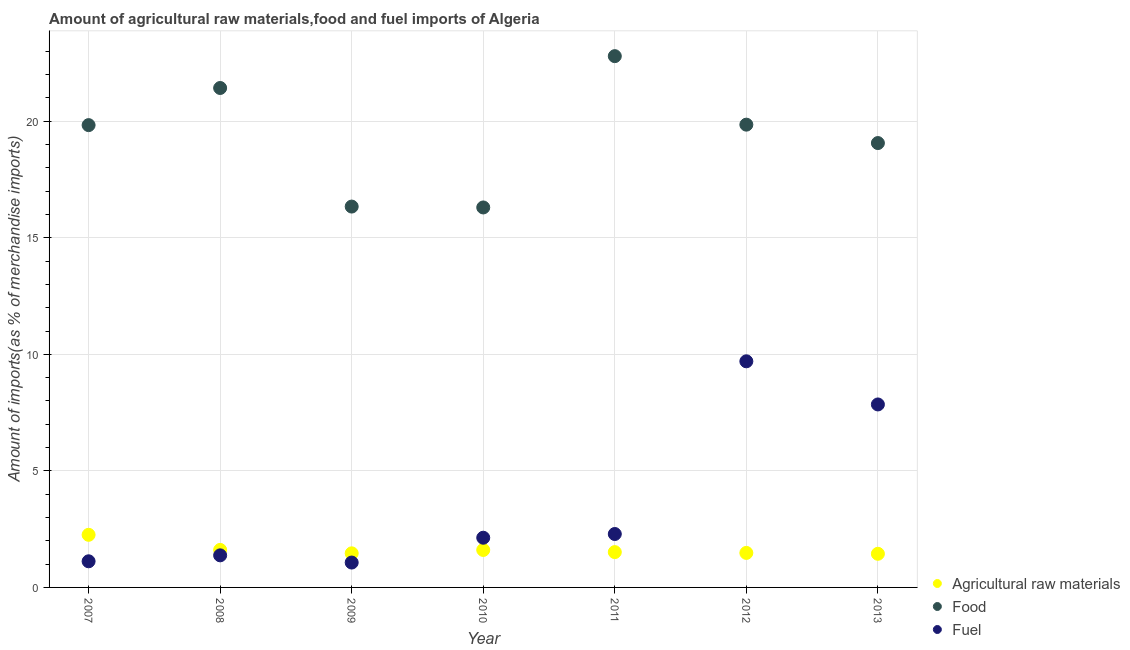What is the percentage of raw materials imports in 2009?
Offer a very short reply. 1.46. Across all years, what is the maximum percentage of food imports?
Provide a succinct answer. 22.79. Across all years, what is the minimum percentage of raw materials imports?
Provide a short and direct response. 1.44. In which year was the percentage of fuel imports maximum?
Your response must be concise. 2012. What is the total percentage of food imports in the graph?
Keep it short and to the point. 135.6. What is the difference between the percentage of raw materials imports in 2007 and that in 2013?
Give a very brief answer. 0.81. What is the difference between the percentage of fuel imports in 2010 and the percentage of raw materials imports in 2008?
Keep it short and to the point. 0.52. What is the average percentage of food imports per year?
Ensure brevity in your answer.  19.37. In the year 2010, what is the difference between the percentage of fuel imports and percentage of food imports?
Provide a short and direct response. -14.17. In how many years, is the percentage of raw materials imports greater than 15 %?
Ensure brevity in your answer.  0. What is the ratio of the percentage of food imports in 2008 to that in 2013?
Offer a very short reply. 1.12. Is the difference between the percentage of raw materials imports in 2011 and 2012 greater than the difference between the percentage of food imports in 2011 and 2012?
Your answer should be compact. No. What is the difference between the highest and the second highest percentage of raw materials imports?
Give a very brief answer. 0.65. What is the difference between the highest and the lowest percentage of raw materials imports?
Offer a terse response. 0.81. Is it the case that in every year, the sum of the percentage of raw materials imports and percentage of food imports is greater than the percentage of fuel imports?
Provide a succinct answer. Yes. How many years are there in the graph?
Provide a succinct answer. 7. What is the difference between two consecutive major ticks on the Y-axis?
Make the answer very short. 5. How are the legend labels stacked?
Keep it short and to the point. Vertical. What is the title of the graph?
Provide a short and direct response. Amount of agricultural raw materials,food and fuel imports of Algeria. Does "Maunufacturing" appear as one of the legend labels in the graph?
Offer a very short reply. No. What is the label or title of the Y-axis?
Offer a terse response. Amount of imports(as % of merchandise imports). What is the Amount of imports(as % of merchandise imports) of Agricultural raw materials in 2007?
Offer a very short reply. 2.26. What is the Amount of imports(as % of merchandise imports) in Food in 2007?
Provide a short and direct response. 19.83. What is the Amount of imports(as % of merchandise imports) in Fuel in 2007?
Offer a terse response. 1.12. What is the Amount of imports(as % of merchandise imports) of Agricultural raw materials in 2008?
Offer a very short reply. 1.61. What is the Amount of imports(as % of merchandise imports) in Food in 2008?
Your answer should be compact. 21.42. What is the Amount of imports(as % of merchandise imports) of Fuel in 2008?
Provide a short and direct response. 1.38. What is the Amount of imports(as % of merchandise imports) in Agricultural raw materials in 2009?
Ensure brevity in your answer.  1.46. What is the Amount of imports(as % of merchandise imports) of Food in 2009?
Ensure brevity in your answer.  16.34. What is the Amount of imports(as % of merchandise imports) in Fuel in 2009?
Make the answer very short. 1.07. What is the Amount of imports(as % of merchandise imports) in Agricultural raw materials in 2010?
Keep it short and to the point. 1.61. What is the Amount of imports(as % of merchandise imports) in Food in 2010?
Provide a succinct answer. 16.3. What is the Amount of imports(as % of merchandise imports) of Fuel in 2010?
Your answer should be very brief. 2.13. What is the Amount of imports(as % of merchandise imports) of Agricultural raw materials in 2011?
Make the answer very short. 1.52. What is the Amount of imports(as % of merchandise imports) in Food in 2011?
Keep it short and to the point. 22.79. What is the Amount of imports(as % of merchandise imports) in Fuel in 2011?
Your answer should be compact. 2.29. What is the Amount of imports(as % of merchandise imports) of Agricultural raw materials in 2012?
Give a very brief answer. 1.48. What is the Amount of imports(as % of merchandise imports) in Food in 2012?
Your answer should be compact. 19.85. What is the Amount of imports(as % of merchandise imports) of Fuel in 2012?
Keep it short and to the point. 9.7. What is the Amount of imports(as % of merchandise imports) of Agricultural raw materials in 2013?
Offer a terse response. 1.44. What is the Amount of imports(as % of merchandise imports) of Food in 2013?
Your answer should be compact. 19.06. What is the Amount of imports(as % of merchandise imports) in Fuel in 2013?
Keep it short and to the point. 7.85. Across all years, what is the maximum Amount of imports(as % of merchandise imports) of Agricultural raw materials?
Offer a very short reply. 2.26. Across all years, what is the maximum Amount of imports(as % of merchandise imports) in Food?
Your answer should be very brief. 22.79. Across all years, what is the maximum Amount of imports(as % of merchandise imports) in Fuel?
Provide a succinct answer. 9.7. Across all years, what is the minimum Amount of imports(as % of merchandise imports) in Agricultural raw materials?
Your answer should be very brief. 1.44. Across all years, what is the minimum Amount of imports(as % of merchandise imports) in Food?
Your answer should be compact. 16.3. Across all years, what is the minimum Amount of imports(as % of merchandise imports) in Fuel?
Your answer should be compact. 1.07. What is the total Amount of imports(as % of merchandise imports) of Agricultural raw materials in the graph?
Your answer should be compact. 11.38. What is the total Amount of imports(as % of merchandise imports) in Food in the graph?
Your response must be concise. 135.6. What is the total Amount of imports(as % of merchandise imports) of Fuel in the graph?
Provide a succinct answer. 25.54. What is the difference between the Amount of imports(as % of merchandise imports) in Agricultural raw materials in 2007 and that in 2008?
Offer a terse response. 0.65. What is the difference between the Amount of imports(as % of merchandise imports) in Food in 2007 and that in 2008?
Offer a terse response. -1.59. What is the difference between the Amount of imports(as % of merchandise imports) in Fuel in 2007 and that in 2008?
Give a very brief answer. -0.25. What is the difference between the Amount of imports(as % of merchandise imports) in Agricultural raw materials in 2007 and that in 2009?
Provide a short and direct response. 0.79. What is the difference between the Amount of imports(as % of merchandise imports) in Food in 2007 and that in 2009?
Keep it short and to the point. 3.49. What is the difference between the Amount of imports(as % of merchandise imports) in Fuel in 2007 and that in 2009?
Offer a terse response. 0.05. What is the difference between the Amount of imports(as % of merchandise imports) of Agricultural raw materials in 2007 and that in 2010?
Keep it short and to the point. 0.65. What is the difference between the Amount of imports(as % of merchandise imports) of Food in 2007 and that in 2010?
Provide a short and direct response. 3.53. What is the difference between the Amount of imports(as % of merchandise imports) in Fuel in 2007 and that in 2010?
Provide a short and direct response. -1.01. What is the difference between the Amount of imports(as % of merchandise imports) in Agricultural raw materials in 2007 and that in 2011?
Give a very brief answer. 0.74. What is the difference between the Amount of imports(as % of merchandise imports) of Food in 2007 and that in 2011?
Make the answer very short. -2.96. What is the difference between the Amount of imports(as % of merchandise imports) in Fuel in 2007 and that in 2011?
Keep it short and to the point. -1.17. What is the difference between the Amount of imports(as % of merchandise imports) in Agricultural raw materials in 2007 and that in 2012?
Keep it short and to the point. 0.78. What is the difference between the Amount of imports(as % of merchandise imports) of Food in 2007 and that in 2012?
Offer a terse response. -0.02. What is the difference between the Amount of imports(as % of merchandise imports) of Fuel in 2007 and that in 2012?
Offer a very short reply. -8.58. What is the difference between the Amount of imports(as % of merchandise imports) of Agricultural raw materials in 2007 and that in 2013?
Provide a short and direct response. 0.81. What is the difference between the Amount of imports(as % of merchandise imports) of Food in 2007 and that in 2013?
Give a very brief answer. 0.77. What is the difference between the Amount of imports(as % of merchandise imports) of Fuel in 2007 and that in 2013?
Offer a terse response. -6.73. What is the difference between the Amount of imports(as % of merchandise imports) in Agricultural raw materials in 2008 and that in 2009?
Ensure brevity in your answer.  0.15. What is the difference between the Amount of imports(as % of merchandise imports) in Food in 2008 and that in 2009?
Keep it short and to the point. 5.09. What is the difference between the Amount of imports(as % of merchandise imports) of Fuel in 2008 and that in 2009?
Your response must be concise. 0.31. What is the difference between the Amount of imports(as % of merchandise imports) in Agricultural raw materials in 2008 and that in 2010?
Offer a terse response. 0. What is the difference between the Amount of imports(as % of merchandise imports) in Food in 2008 and that in 2010?
Offer a terse response. 5.12. What is the difference between the Amount of imports(as % of merchandise imports) in Fuel in 2008 and that in 2010?
Ensure brevity in your answer.  -0.76. What is the difference between the Amount of imports(as % of merchandise imports) of Agricultural raw materials in 2008 and that in 2011?
Give a very brief answer. 0.09. What is the difference between the Amount of imports(as % of merchandise imports) of Food in 2008 and that in 2011?
Offer a very short reply. -1.37. What is the difference between the Amount of imports(as % of merchandise imports) of Fuel in 2008 and that in 2011?
Your answer should be very brief. -0.92. What is the difference between the Amount of imports(as % of merchandise imports) of Agricultural raw materials in 2008 and that in 2012?
Give a very brief answer. 0.13. What is the difference between the Amount of imports(as % of merchandise imports) in Food in 2008 and that in 2012?
Provide a short and direct response. 1.57. What is the difference between the Amount of imports(as % of merchandise imports) of Fuel in 2008 and that in 2012?
Your response must be concise. -8.32. What is the difference between the Amount of imports(as % of merchandise imports) in Agricultural raw materials in 2008 and that in 2013?
Your answer should be compact. 0.17. What is the difference between the Amount of imports(as % of merchandise imports) of Food in 2008 and that in 2013?
Give a very brief answer. 2.36. What is the difference between the Amount of imports(as % of merchandise imports) in Fuel in 2008 and that in 2013?
Ensure brevity in your answer.  -6.47. What is the difference between the Amount of imports(as % of merchandise imports) of Agricultural raw materials in 2009 and that in 2010?
Offer a terse response. -0.14. What is the difference between the Amount of imports(as % of merchandise imports) in Food in 2009 and that in 2010?
Keep it short and to the point. 0.04. What is the difference between the Amount of imports(as % of merchandise imports) in Fuel in 2009 and that in 2010?
Offer a terse response. -1.06. What is the difference between the Amount of imports(as % of merchandise imports) of Agricultural raw materials in 2009 and that in 2011?
Offer a terse response. -0.05. What is the difference between the Amount of imports(as % of merchandise imports) of Food in 2009 and that in 2011?
Ensure brevity in your answer.  -6.45. What is the difference between the Amount of imports(as % of merchandise imports) of Fuel in 2009 and that in 2011?
Offer a very short reply. -1.23. What is the difference between the Amount of imports(as % of merchandise imports) of Agricultural raw materials in 2009 and that in 2012?
Provide a succinct answer. -0.02. What is the difference between the Amount of imports(as % of merchandise imports) in Food in 2009 and that in 2012?
Your response must be concise. -3.51. What is the difference between the Amount of imports(as % of merchandise imports) of Fuel in 2009 and that in 2012?
Provide a succinct answer. -8.63. What is the difference between the Amount of imports(as % of merchandise imports) in Food in 2009 and that in 2013?
Provide a succinct answer. -2.72. What is the difference between the Amount of imports(as % of merchandise imports) of Fuel in 2009 and that in 2013?
Make the answer very short. -6.78. What is the difference between the Amount of imports(as % of merchandise imports) of Agricultural raw materials in 2010 and that in 2011?
Your response must be concise. 0.09. What is the difference between the Amount of imports(as % of merchandise imports) in Food in 2010 and that in 2011?
Ensure brevity in your answer.  -6.49. What is the difference between the Amount of imports(as % of merchandise imports) in Fuel in 2010 and that in 2011?
Keep it short and to the point. -0.16. What is the difference between the Amount of imports(as % of merchandise imports) of Agricultural raw materials in 2010 and that in 2012?
Keep it short and to the point. 0.13. What is the difference between the Amount of imports(as % of merchandise imports) in Food in 2010 and that in 2012?
Offer a terse response. -3.55. What is the difference between the Amount of imports(as % of merchandise imports) in Fuel in 2010 and that in 2012?
Make the answer very short. -7.57. What is the difference between the Amount of imports(as % of merchandise imports) in Agricultural raw materials in 2010 and that in 2013?
Give a very brief answer. 0.16. What is the difference between the Amount of imports(as % of merchandise imports) of Food in 2010 and that in 2013?
Make the answer very short. -2.76. What is the difference between the Amount of imports(as % of merchandise imports) in Fuel in 2010 and that in 2013?
Give a very brief answer. -5.72. What is the difference between the Amount of imports(as % of merchandise imports) of Agricultural raw materials in 2011 and that in 2012?
Your response must be concise. 0.03. What is the difference between the Amount of imports(as % of merchandise imports) of Food in 2011 and that in 2012?
Your answer should be very brief. 2.94. What is the difference between the Amount of imports(as % of merchandise imports) of Fuel in 2011 and that in 2012?
Offer a very short reply. -7.41. What is the difference between the Amount of imports(as % of merchandise imports) in Agricultural raw materials in 2011 and that in 2013?
Your response must be concise. 0.07. What is the difference between the Amount of imports(as % of merchandise imports) of Food in 2011 and that in 2013?
Keep it short and to the point. 3.73. What is the difference between the Amount of imports(as % of merchandise imports) of Fuel in 2011 and that in 2013?
Give a very brief answer. -5.56. What is the difference between the Amount of imports(as % of merchandise imports) of Agricultural raw materials in 2012 and that in 2013?
Your response must be concise. 0.04. What is the difference between the Amount of imports(as % of merchandise imports) of Food in 2012 and that in 2013?
Your answer should be very brief. 0.79. What is the difference between the Amount of imports(as % of merchandise imports) of Fuel in 2012 and that in 2013?
Give a very brief answer. 1.85. What is the difference between the Amount of imports(as % of merchandise imports) in Agricultural raw materials in 2007 and the Amount of imports(as % of merchandise imports) in Food in 2008?
Provide a short and direct response. -19.17. What is the difference between the Amount of imports(as % of merchandise imports) in Agricultural raw materials in 2007 and the Amount of imports(as % of merchandise imports) in Fuel in 2008?
Give a very brief answer. 0.88. What is the difference between the Amount of imports(as % of merchandise imports) of Food in 2007 and the Amount of imports(as % of merchandise imports) of Fuel in 2008?
Provide a short and direct response. 18.46. What is the difference between the Amount of imports(as % of merchandise imports) in Agricultural raw materials in 2007 and the Amount of imports(as % of merchandise imports) in Food in 2009?
Offer a terse response. -14.08. What is the difference between the Amount of imports(as % of merchandise imports) in Agricultural raw materials in 2007 and the Amount of imports(as % of merchandise imports) in Fuel in 2009?
Give a very brief answer. 1.19. What is the difference between the Amount of imports(as % of merchandise imports) in Food in 2007 and the Amount of imports(as % of merchandise imports) in Fuel in 2009?
Your response must be concise. 18.77. What is the difference between the Amount of imports(as % of merchandise imports) in Agricultural raw materials in 2007 and the Amount of imports(as % of merchandise imports) in Food in 2010?
Keep it short and to the point. -14.04. What is the difference between the Amount of imports(as % of merchandise imports) in Agricultural raw materials in 2007 and the Amount of imports(as % of merchandise imports) in Fuel in 2010?
Your answer should be very brief. 0.13. What is the difference between the Amount of imports(as % of merchandise imports) of Food in 2007 and the Amount of imports(as % of merchandise imports) of Fuel in 2010?
Provide a succinct answer. 17.7. What is the difference between the Amount of imports(as % of merchandise imports) of Agricultural raw materials in 2007 and the Amount of imports(as % of merchandise imports) of Food in 2011?
Your answer should be compact. -20.53. What is the difference between the Amount of imports(as % of merchandise imports) of Agricultural raw materials in 2007 and the Amount of imports(as % of merchandise imports) of Fuel in 2011?
Keep it short and to the point. -0.03. What is the difference between the Amount of imports(as % of merchandise imports) of Food in 2007 and the Amount of imports(as % of merchandise imports) of Fuel in 2011?
Provide a short and direct response. 17.54. What is the difference between the Amount of imports(as % of merchandise imports) of Agricultural raw materials in 2007 and the Amount of imports(as % of merchandise imports) of Food in 2012?
Offer a very short reply. -17.6. What is the difference between the Amount of imports(as % of merchandise imports) of Agricultural raw materials in 2007 and the Amount of imports(as % of merchandise imports) of Fuel in 2012?
Make the answer very short. -7.44. What is the difference between the Amount of imports(as % of merchandise imports) in Food in 2007 and the Amount of imports(as % of merchandise imports) in Fuel in 2012?
Keep it short and to the point. 10.13. What is the difference between the Amount of imports(as % of merchandise imports) of Agricultural raw materials in 2007 and the Amount of imports(as % of merchandise imports) of Food in 2013?
Offer a terse response. -16.81. What is the difference between the Amount of imports(as % of merchandise imports) of Agricultural raw materials in 2007 and the Amount of imports(as % of merchandise imports) of Fuel in 2013?
Offer a very short reply. -5.59. What is the difference between the Amount of imports(as % of merchandise imports) in Food in 2007 and the Amount of imports(as % of merchandise imports) in Fuel in 2013?
Give a very brief answer. 11.98. What is the difference between the Amount of imports(as % of merchandise imports) in Agricultural raw materials in 2008 and the Amount of imports(as % of merchandise imports) in Food in 2009?
Offer a terse response. -14.73. What is the difference between the Amount of imports(as % of merchandise imports) in Agricultural raw materials in 2008 and the Amount of imports(as % of merchandise imports) in Fuel in 2009?
Ensure brevity in your answer.  0.54. What is the difference between the Amount of imports(as % of merchandise imports) of Food in 2008 and the Amount of imports(as % of merchandise imports) of Fuel in 2009?
Offer a terse response. 20.36. What is the difference between the Amount of imports(as % of merchandise imports) in Agricultural raw materials in 2008 and the Amount of imports(as % of merchandise imports) in Food in 2010?
Offer a very short reply. -14.69. What is the difference between the Amount of imports(as % of merchandise imports) in Agricultural raw materials in 2008 and the Amount of imports(as % of merchandise imports) in Fuel in 2010?
Your answer should be compact. -0.52. What is the difference between the Amount of imports(as % of merchandise imports) in Food in 2008 and the Amount of imports(as % of merchandise imports) in Fuel in 2010?
Your answer should be compact. 19.29. What is the difference between the Amount of imports(as % of merchandise imports) in Agricultural raw materials in 2008 and the Amount of imports(as % of merchandise imports) in Food in 2011?
Give a very brief answer. -21.18. What is the difference between the Amount of imports(as % of merchandise imports) in Agricultural raw materials in 2008 and the Amount of imports(as % of merchandise imports) in Fuel in 2011?
Give a very brief answer. -0.68. What is the difference between the Amount of imports(as % of merchandise imports) of Food in 2008 and the Amount of imports(as % of merchandise imports) of Fuel in 2011?
Make the answer very short. 19.13. What is the difference between the Amount of imports(as % of merchandise imports) of Agricultural raw materials in 2008 and the Amount of imports(as % of merchandise imports) of Food in 2012?
Offer a very short reply. -18.24. What is the difference between the Amount of imports(as % of merchandise imports) in Agricultural raw materials in 2008 and the Amount of imports(as % of merchandise imports) in Fuel in 2012?
Give a very brief answer. -8.09. What is the difference between the Amount of imports(as % of merchandise imports) in Food in 2008 and the Amount of imports(as % of merchandise imports) in Fuel in 2012?
Offer a terse response. 11.72. What is the difference between the Amount of imports(as % of merchandise imports) in Agricultural raw materials in 2008 and the Amount of imports(as % of merchandise imports) in Food in 2013?
Your answer should be very brief. -17.45. What is the difference between the Amount of imports(as % of merchandise imports) of Agricultural raw materials in 2008 and the Amount of imports(as % of merchandise imports) of Fuel in 2013?
Keep it short and to the point. -6.24. What is the difference between the Amount of imports(as % of merchandise imports) in Food in 2008 and the Amount of imports(as % of merchandise imports) in Fuel in 2013?
Your answer should be compact. 13.58. What is the difference between the Amount of imports(as % of merchandise imports) in Agricultural raw materials in 2009 and the Amount of imports(as % of merchandise imports) in Food in 2010?
Provide a succinct answer. -14.84. What is the difference between the Amount of imports(as % of merchandise imports) of Agricultural raw materials in 2009 and the Amount of imports(as % of merchandise imports) of Fuel in 2010?
Make the answer very short. -0.67. What is the difference between the Amount of imports(as % of merchandise imports) in Food in 2009 and the Amount of imports(as % of merchandise imports) in Fuel in 2010?
Keep it short and to the point. 14.21. What is the difference between the Amount of imports(as % of merchandise imports) of Agricultural raw materials in 2009 and the Amount of imports(as % of merchandise imports) of Food in 2011?
Provide a succinct answer. -21.33. What is the difference between the Amount of imports(as % of merchandise imports) in Agricultural raw materials in 2009 and the Amount of imports(as % of merchandise imports) in Fuel in 2011?
Provide a short and direct response. -0.83. What is the difference between the Amount of imports(as % of merchandise imports) of Food in 2009 and the Amount of imports(as % of merchandise imports) of Fuel in 2011?
Provide a short and direct response. 14.05. What is the difference between the Amount of imports(as % of merchandise imports) in Agricultural raw materials in 2009 and the Amount of imports(as % of merchandise imports) in Food in 2012?
Offer a very short reply. -18.39. What is the difference between the Amount of imports(as % of merchandise imports) of Agricultural raw materials in 2009 and the Amount of imports(as % of merchandise imports) of Fuel in 2012?
Offer a terse response. -8.24. What is the difference between the Amount of imports(as % of merchandise imports) in Food in 2009 and the Amount of imports(as % of merchandise imports) in Fuel in 2012?
Your response must be concise. 6.64. What is the difference between the Amount of imports(as % of merchandise imports) in Agricultural raw materials in 2009 and the Amount of imports(as % of merchandise imports) in Food in 2013?
Your answer should be compact. -17.6. What is the difference between the Amount of imports(as % of merchandise imports) in Agricultural raw materials in 2009 and the Amount of imports(as % of merchandise imports) in Fuel in 2013?
Your answer should be compact. -6.39. What is the difference between the Amount of imports(as % of merchandise imports) of Food in 2009 and the Amount of imports(as % of merchandise imports) of Fuel in 2013?
Provide a succinct answer. 8.49. What is the difference between the Amount of imports(as % of merchandise imports) in Agricultural raw materials in 2010 and the Amount of imports(as % of merchandise imports) in Food in 2011?
Make the answer very short. -21.18. What is the difference between the Amount of imports(as % of merchandise imports) in Agricultural raw materials in 2010 and the Amount of imports(as % of merchandise imports) in Fuel in 2011?
Your response must be concise. -0.68. What is the difference between the Amount of imports(as % of merchandise imports) of Food in 2010 and the Amount of imports(as % of merchandise imports) of Fuel in 2011?
Make the answer very short. 14.01. What is the difference between the Amount of imports(as % of merchandise imports) in Agricultural raw materials in 2010 and the Amount of imports(as % of merchandise imports) in Food in 2012?
Offer a terse response. -18.24. What is the difference between the Amount of imports(as % of merchandise imports) of Agricultural raw materials in 2010 and the Amount of imports(as % of merchandise imports) of Fuel in 2012?
Make the answer very short. -8.09. What is the difference between the Amount of imports(as % of merchandise imports) of Food in 2010 and the Amount of imports(as % of merchandise imports) of Fuel in 2012?
Your answer should be very brief. 6.6. What is the difference between the Amount of imports(as % of merchandise imports) in Agricultural raw materials in 2010 and the Amount of imports(as % of merchandise imports) in Food in 2013?
Your response must be concise. -17.46. What is the difference between the Amount of imports(as % of merchandise imports) in Agricultural raw materials in 2010 and the Amount of imports(as % of merchandise imports) in Fuel in 2013?
Your answer should be very brief. -6.24. What is the difference between the Amount of imports(as % of merchandise imports) in Food in 2010 and the Amount of imports(as % of merchandise imports) in Fuel in 2013?
Keep it short and to the point. 8.45. What is the difference between the Amount of imports(as % of merchandise imports) in Agricultural raw materials in 2011 and the Amount of imports(as % of merchandise imports) in Food in 2012?
Provide a short and direct response. -18.34. What is the difference between the Amount of imports(as % of merchandise imports) in Agricultural raw materials in 2011 and the Amount of imports(as % of merchandise imports) in Fuel in 2012?
Your answer should be compact. -8.18. What is the difference between the Amount of imports(as % of merchandise imports) in Food in 2011 and the Amount of imports(as % of merchandise imports) in Fuel in 2012?
Keep it short and to the point. 13.09. What is the difference between the Amount of imports(as % of merchandise imports) in Agricultural raw materials in 2011 and the Amount of imports(as % of merchandise imports) in Food in 2013?
Your answer should be very brief. -17.55. What is the difference between the Amount of imports(as % of merchandise imports) of Agricultural raw materials in 2011 and the Amount of imports(as % of merchandise imports) of Fuel in 2013?
Ensure brevity in your answer.  -6.33. What is the difference between the Amount of imports(as % of merchandise imports) in Food in 2011 and the Amount of imports(as % of merchandise imports) in Fuel in 2013?
Provide a short and direct response. 14.94. What is the difference between the Amount of imports(as % of merchandise imports) of Agricultural raw materials in 2012 and the Amount of imports(as % of merchandise imports) of Food in 2013?
Provide a short and direct response. -17.58. What is the difference between the Amount of imports(as % of merchandise imports) in Agricultural raw materials in 2012 and the Amount of imports(as % of merchandise imports) in Fuel in 2013?
Make the answer very short. -6.37. What is the difference between the Amount of imports(as % of merchandise imports) in Food in 2012 and the Amount of imports(as % of merchandise imports) in Fuel in 2013?
Provide a short and direct response. 12. What is the average Amount of imports(as % of merchandise imports) in Agricultural raw materials per year?
Provide a short and direct response. 1.63. What is the average Amount of imports(as % of merchandise imports) in Food per year?
Make the answer very short. 19.37. What is the average Amount of imports(as % of merchandise imports) in Fuel per year?
Your response must be concise. 3.65. In the year 2007, what is the difference between the Amount of imports(as % of merchandise imports) of Agricultural raw materials and Amount of imports(as % of merchandise imports) of Food?
Keep it short and to the point. -17.58. In the year 2007, what is the difference between the Amount of imports(as % of merchandise imports) in Agricultural raw materials and Amount of imports(as % of merchandise imports) in Fuel?
Provide a succinct answer. 1.14. In the year 2007, what is the difference between the Amount of imports(as % of merchandise imports) in Food and Amount of imports(as % of merchandise imports) in Fuel?
Offer a very short reply. 18.71. In the year 2008, what is the difference between the Amount of imports(as % of merchandise imports) of Agricultural raw materials and Amount of imports(as % of merchandise imports) of Food?
Ensure brevity in your answer.  -19.82. In the year 2008, what is the difference between the Amount of imports(as % of merchandise imports) in Agricultural raw materials and Amount of imports(as % of merchandise imports) in Fuel?
Offer a terse response. 0.23. In the year 2008, what is the difference between the Amount of imports(as % of merchandise imports) of Food and Amount of imports(as % of merchandise imports) of Fuel?
Provide a succinct answer. 20.05. In the year 2009, what is the difference between the Amount of imports(as % of merchandise imports) of Agricultural raw materials and Amount of imports(as % of merchandise imports) of Food?
Offer a terse response. -14.88. In the year 2009, what is the difference between the Amount of imports(as % of merchandise imports) in Agricultural raw materials and Amount of imports(as % of merchandise imports) in Fuel?
Your answer should be very brief. 0.4. In the year 2009, what is the difference between the Amount of imports(as % of merchandise imports) in Food and Amount of imports(as % of merchandise imports) in Fuel?
Offer a terse response. 15.27. In the year 2010, what is the difference between the Amount of imports(as % of merchandise imports) of Agricultural raw materials and Amount of imports(as % of merchandise imports) of Food?
Provide a succinct answer. -14.69. In the year 2010, what is the difference between the Amount of imports(as % of merchandise imports) of Agricultural raw materials and Amount of imports(as % of merchandise imports) of Fuel?
Ensure brevity in your answer.  -0.52. In the year 2010, what is the difference between the Amount of imports(as % of merchandise imports) in Food and Amount of imports(as % of merchandise imports) in Fuel?
Provide a short and direct response. 14.17. In the year 2011, what is the difference between the Amount of imports(as % of merchandise imports) of Agricultural raw materials and Amount of imports(as % of merchandise imports) of Food?
Your answer should be compact. -21.28. In the year 2011, what is the difference between the Amount of imports(as % of merchandise imports) of Agricultural raw materials and Amount of imports(as % of merchandise imports) of Fuel?
Offer a terse response. -0.78. In the year 2011, what is the difference between the Amount of imports(as % of merchandise imports) in Food and Amount of imports(as % of merchandise imports) in Fuel?
Make the answer very short. 20.5. In the year 2012, what is the difference between the Amount of imports(as % of merchandise imports) of Agricultural raw materials and Amount of imports(as % of merchandise imports) of Food?
Make the answer very short. -18.37. In the year 2012, what is the difference between the Amount of imports(as % of merchandise imports) in Agricultural raw materials and Amount of imports(as % of merchandise imports) in Fuel?
Your answer should be very brief. -8.22. In the year 2012, what is the difference between the Amount of imports(as % of merchandise imports) of Food and Amount of imports(as % of merchandise imports) of Fuel?
Ensure brevity in your answer.  10.15. In the year 2013, what is the difference between the Amount of imports(as % of merchandise imports) in Agricultural raw materials and Amount of imports(as % of merchandise imports) in Food?
Keep it short and to the point. -17.62. In the year 2013, what is the difference between the Amount of imports(as % of merchandise imports) in Agricultural raw materials and Amount of imports(as % of merchandise imports) in Fuel?
Offer a terse response. -6.41. In the year 2013, what is the difference between the Amount of imports(as % of merchandise imports) of Food and Amount of imports(as % of merchandise imports) of Fuel?
Your answer should be very brief. 11.21. What is the ratio of the Amount of imports(as % of merchandise imports) of Agricultural raw materials in 2007 to that in 2008?
Keep it short and to the point. 1.4. What is the ratio of the Amount of imports(as % of merchandise imports) of Food in 2007 to that in 2008?
Provide a succinct answer. 0.93. What is the ratio of the Amount of imports(as % of merchandise imports) of Fuel in 2007 to that in 2008?
Offer a terse response. 0.81. What is the ratio of the Amount of imports(as % of merchandise imports) of Agricultural raw materials in 2007 to that in 2009?
Provide a succinct answer. 1.54. What is the ratio of the Amount of imports(as % of merchandise imports) of Food in 2007 to that in 2009?
Provide a short and direct response. 1.21. What is the ratio of the Amount of imports(as % of merchandise imports) in Fuel in 2007 to that in 2009?
Provide a succinct answer. 1.05. What is the ratio of the Amount of imports(as % of merchandise imports) in Agricultural raw materials in 2007 to that in 2010?
Keep it short and to the point. 1.4. What is the ratio of the Amount of imports(as % of merchandise imports) in Food in 2007 to that in 2010?
Your response must be concise. 1.22. What is the ratio of the Amount of imports(as % of merchandise imports) of Fuel in 2007 to that in 2010?
Your answer should be compact. 0.53. What is the ratio of the Amount of imports(as % of merchandise imports) of Agricultural raw materials in 2007 to that in 2011?
Your answer should be compact. 1.49. What is the ratio of the Amount of imports(as % of merchandise imports) in Food in 2007 to that in 2011?
Your answer should be compact. 0.87. What is the ratio of the Amount of imports(as % of merchandise imports) of Fuel in 2007 to that in 2011?
Keep it short and to the point. 0.49. What is the ratio of the Amount of imports(as % of merchandise imports) in Agricultural raw materials in 2007 to that in 2012?
Provide a short and direct response. 1.52. What is the ratio of the Amount of imports(as % of merchandise imports) in Food in 2007 to that in 2012?
Ensure brevity in your answer.  1. What is the ratio of the Amount of imports(as % of merchandise imports) of Fuel in 2007 to that in 2012?
Keep it short and to the point. 0.12. What is the ratio of the Amount of imports(as % of merchandise imports) in Agricultural raw materials in 2007 to that in 2013?
Offer a very short reply. 1.56. What is the ratio of the Amount of imports(as % of merchandise imports) of Food in 2007 to that in 2013?
Keep it short and to the point. 1.04. What is the ratio of the Amount of imports(as % of merchandise imports) of Fuel in 2007 to that in 2013?
Offer a terse response. 0.14. What is the ratio of the Amount of imports(as % of merchandise imports) of Agricultural raw materials in 2008 to that in 2009?
Your response must be concise. 1.1. What is the ratio of the Amount of imports(as % of merchandise imports) in Food in 2008 to that in 2009?
Your answer should be compact. 1.31. What is the ratio of the Amount of imports(as % of merchandise imports) of Fuel in 2008 to that in 2009?
Your answer should be very brief. 1.29. What is the ratio of the Amount of imports(as % of merchandise imports) in Agricultural raw materials in 2008 to that in 2010?
Your response must be concise. 1. What is the ratio of the Amount of imports(as % of merchandise imports) in Food in 2008 to that in 2010?
Give a very brief answer. 1.31. What is the ratio of the Amount of imports(as % of merchandise imports) in Fuel in 2008 to that in 2010?
Keep it short and to the point. 0.65. What is the ratio of the Amount of imports(as % of merchandise imports) of Agricultural raw materials in 2008 to that in 2011?
Your response must be concise. 1.06. What is the ratio of the Amount of imports(as % of merchandise imports) of Food in 2008 to that in 2011?
Provide a succinct answer. 0.94. What is the ratio of the Amount of imports(as % of merchandise imports) in Fuel in 2008 to that in 2011?
Offer a terse response. 0.6. What is the ratio of the Amount of imports(as % of merchandise imports) in Agricultural raw materials in 2008 to that in 2012?
Offer a terse response. 1.09. What is the ratio of the Amount of imports(as % of merchandise imports) of Food in 2008 to that in 2012?
Give a very brief answer. 1.08. What is the ratio of the Amount of imports(as % of merchandise imports) in Fuel in 2008 to that in 2012?
Keep it short and to the point. 0.14. What is the ratio of the Amount of imports(as % of merchandise imports) of Agricultural raw materials in 2008 to that in 2013?
Make the answer very short. 1.12. What is the ratio of the Amount of imports(as % of merchandise imports) of Food in 2008 to that in 2013?
Provide a succinct answer. 1.12. What is the ratio of the Amount of imports(as % of merchandise imports) in Fuel in 2008 to that in 2013?
Keep it short and to the point. 0.18. What is the ratio of the Amount of imports(as % of merchandise imports) of Agricultural raw materials in 2009 to that in 2010?
Make the answer very short. 0.91. What is the ratio of the Amount of imports(as % of merchandise imports) of Food in 2009 to that in 2010?
Ensure brevity in your answer.  1. What is the ratio of the Amount of imports(as % of merchandise imports) in Fuel in 2009 to that in 2010?
Make the answer very short. 0.5. What is the ratio of the Amount of imports(as % of merchandise imports) of Agricultural raw materials in 2009 to that in 2011?
Your answer should be very brief. 0.97. What is the ratio of the Amount of imports(as % of merchandise imports) of Food in 2009 to that in 2011?
Give a very brief answer. 0.72. What is the ratio of the Amount of imports(as % of merchandise imports) of Fuel in 2009 to that in 2011?
Your response must be concise. 0.47. What is the ratio of the Amount of imports(as % of merchandise imports) in Food in 2009 to that in 2012?
Your answer should be very brief. 0.82. What is the ratio of the Amount of imports(as % of merchandise imports) in Fuel in 2009 to that in 2012?
Offer a very short reply. 0.11. What is the ratio of the Amount of imports(as % of merchandise imports) of Agricultural raw materials in 2009 to that in 2013?
Your answer should be compact. 1.01. What is the ratio of the Amount of imports(as % of merchandise imports) of Food in 2009 to that in 2013?
Make the answer very short. 0.86. What is the ratio of the Amount of imports(as % of merchandise imports) in Fuel in 2009 to that in 2013?
Your answer should be very brief. 0.14. What is the ratio of the Amount of imports(as % of merchandise imports) of Agricultural raw materials in 2010 to that in 2011?
Give a very brief answer. 1.06. What is the ratio of the Amount of imports(as % of merchandise imports) of Food in 2010 to that in 2011?
Offer a terse response. 0.72. What is the ratio of the Amount of imports(as % of merchandise imports) in Fuel in 2010 to that in 2011?
Offer a very short reply. 0.93. What is the ratio of the Amount of imports(as % of merchandise imports) in Agricultural raw materials in 2010 to that in 2012?
Offer a terse response. 1.09. What is the ratio of the Amount of imports(as % of merchandise imports) of Food in 2010 to that in 2012?
Offer a very short reply. 0.82. What is the ratio of the Amount of imports(as % of merchandise imports) in Fuel in 2010 to that in 2012?
Offer a very short reply. 0.22. What is the ratio of the Amount of imports(as % of merchandise imports) of Agricultural raw materials in 2010 to that in 2013?
Your response must be concise. 1.11. What is the ratio of the Amount of imports(as % of merchandise imports) in Food in 2010 to that in 2013?
Ensure brevity in your answer.  0.86. What is the ratio of the Amount of imports(as % of merchandise imports) of Fuel in 2010 to that in 2013?
Make the answer very short. 0.27. What is the ratio of the Amount of imports(as % of merchandise imports) of Agricultural raw materials in 2011 to that in 2012?
Make the answer very short. 1.02. What is the ratio of the Amount of imports(as % of merchandise imports) of Food in 2011 to that in 2012?
Offer a very short reply. 1.15. What is the ratio of the Amount of imports(as % of merchandise imports) in Fuel in 2011 to that in 2012?
Provide a short and direct response. 0.24. What is the ratio of the Amount of imports(as % of merchandise imports) of Agricultural raw materials in 2011 to that in 2013?
Your response must be concise. 1.05. What is the ratio of the Amount of imports(as % of merchandise imports) of Food in 2011 to that in 2013?
Make the answer very short. 1.2. What is the ratio of the Amount of imports(as % of merchandise imports) in Fuel in 2011 to that in 2013?
Give a very brief answer. 0.29. What is the ratio of the Amount of imports(as % of merchandise imports) in Agricultural raw materials in 2012 to that in 2013?
Offer a very short reply. 1.03. What is the ratio of the Amount of imports(as % of merchandise imports) of Food in 2012 to that in 2013?
Give a very brief answer. 1.04. What is the ratio of the Amount of imports(as % of merchandise imports) in Fuel in 2012 to that in 2013?
Give a very brief answer. 1.24. What is the difference between the highest and the second highest Amount of imports(as % of merchandise imports) of Agricultural raw materials?
Ensure brevity in your answer.  0.65. What is the difference between the highest and the second highest Amount of imports(as % of merchandise imports) of Food?
Offer a very short reply. 1.37. What is the difference between the highest and the second highest Amount of imports(as % of merchandise imports) in Fuel?
Provide a short and direct response. 1.85. What is the difference between the highest and the lowest Amount of imports(as % of merchandise imports) of Agricultural raw materials?
Provide a succinct answer. 0.81. What is the difference between the highest and the lowest Amount of imports(as % of merchandise imports) in Food?
Your response must be concise. 6.49. What is the difference between the highest and the lowest Amount of imports(as % of merchandise imports) in Fuel?
Offer a very short reply. 8.63. 